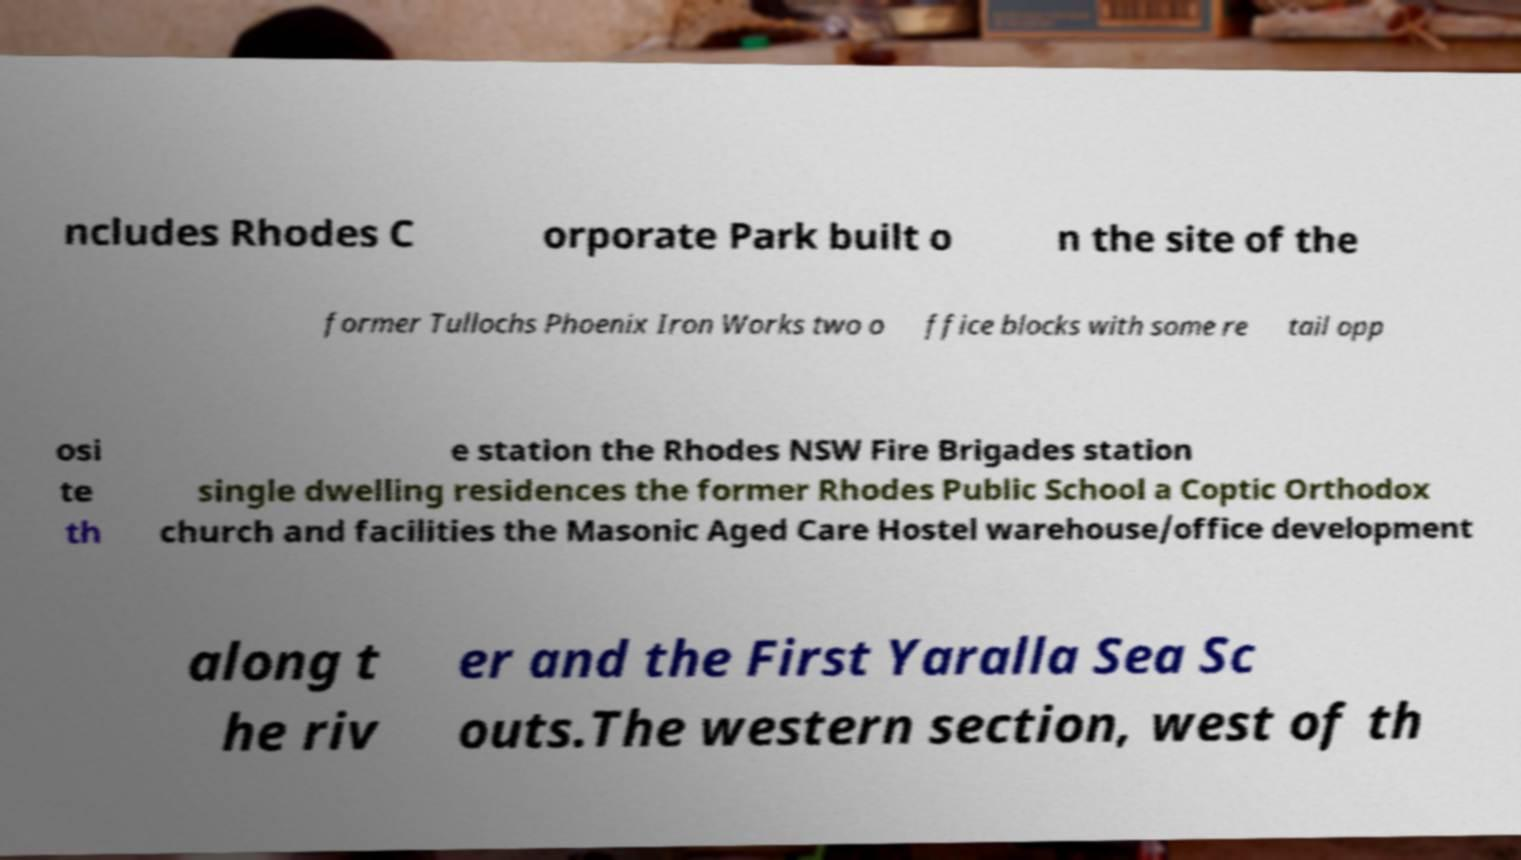What messages or text are displayed in this image? I need them in a readable, typed format. ncludes Rhodes C orporate Park built o n the site of the former Tullochs Phoenix Iron Works two o ffice blocks with some re tail opp osi te th e station the Rhodes NSW Fire Brigades station single dwelling residences the former Rhodes Public School a Coptic Orthodox church and facilities the Masonic Aged Care Hostel warehouse/office development along t he riv er and the First Yaralla Sea Sc outs.The western section, west of th 